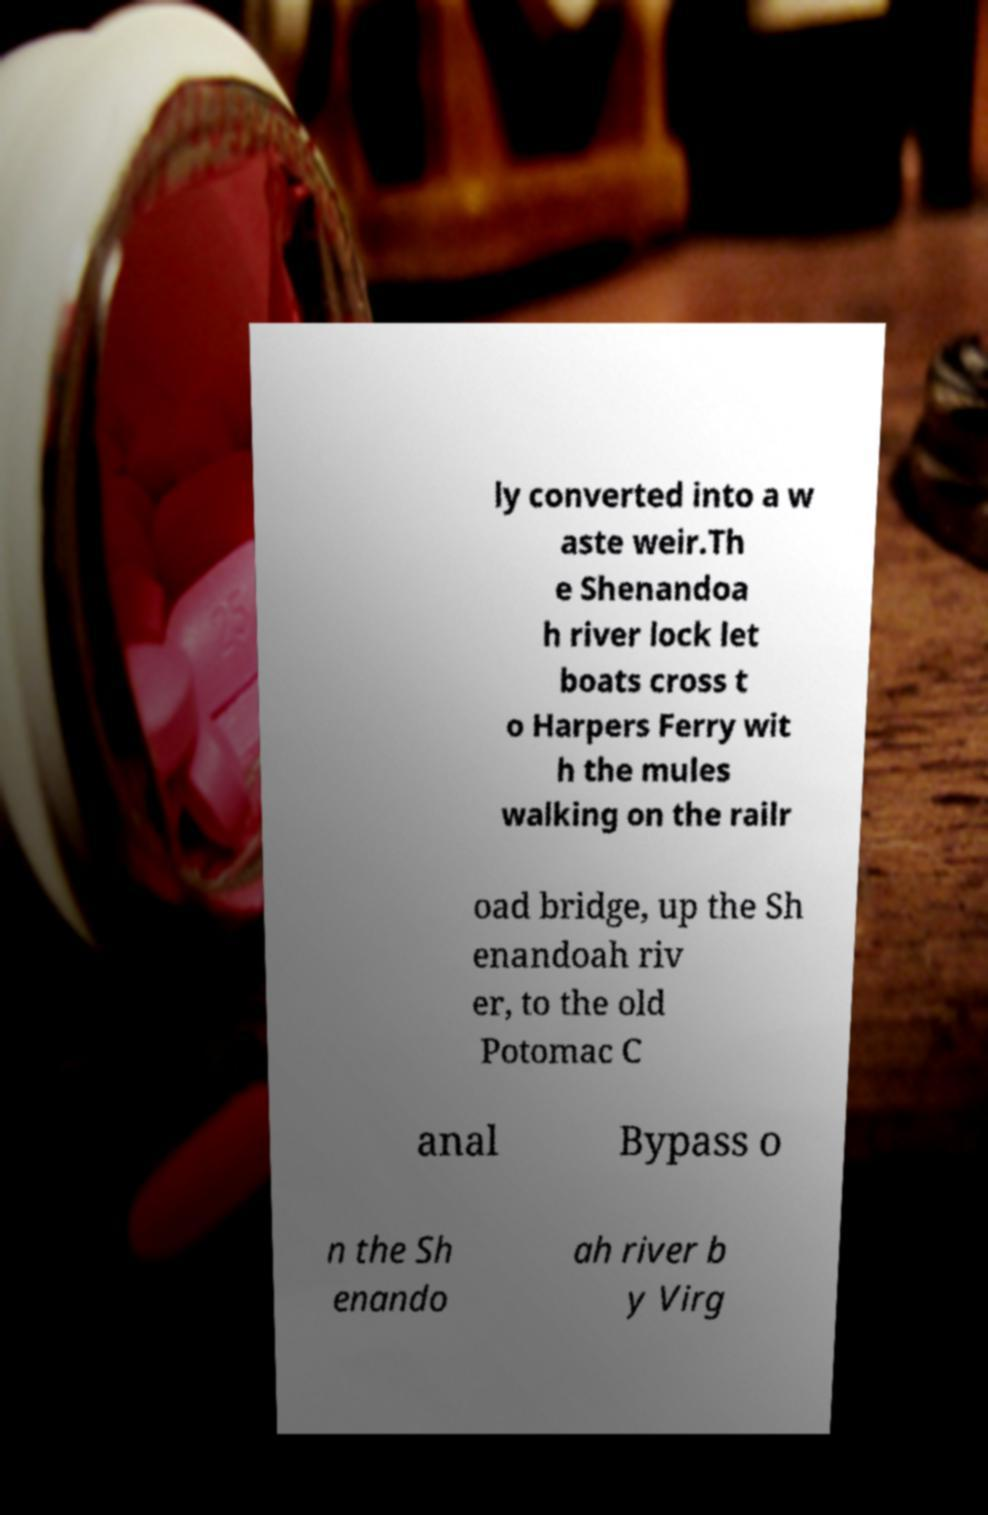Can you read and provide the text displayed in the image?This photo seems to have some interesting text. Can you extract and type it out for me? ly converted into a w aste weir.Th e Shenandoa h river lock let boats cross t o Harpers Ferry wit h the mules walking on the railr oad bridge, up the Sh enandoah riv er, to the old Potomac C anal Bypass o n the Sh enando ah river b y Virg 